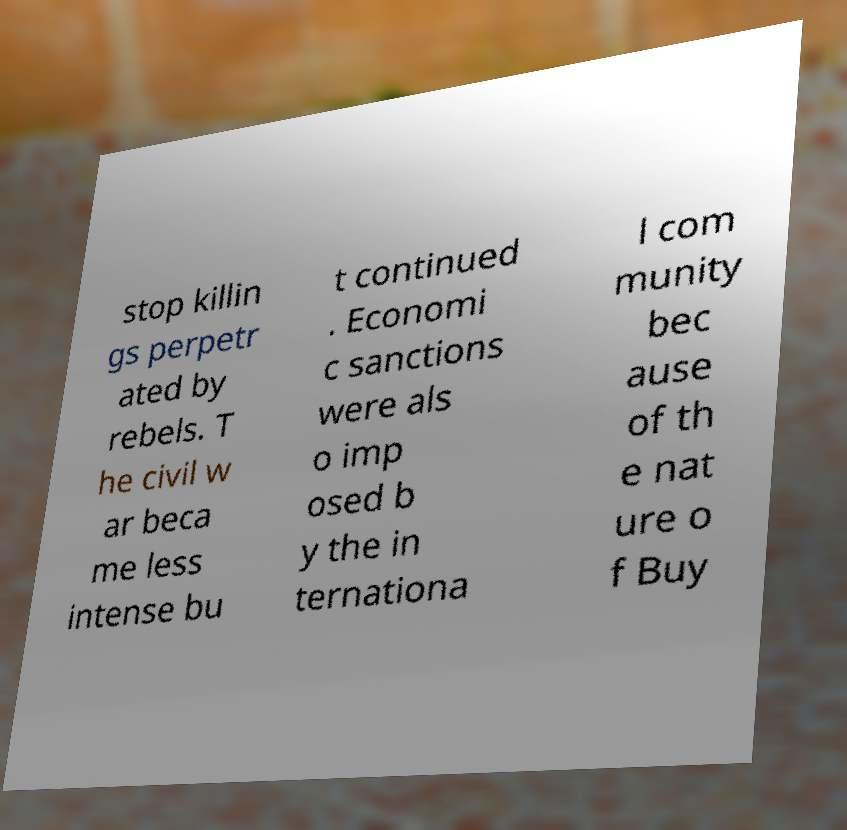For documentation purposes, I need the text within this image transcribed. Could you provide that? stop killin gs perpetr ated by rebels. T he civil w ar beca me less intense bu t continued . Economi c sanctions were als o imp osed b y the in ternationa l com munity bec ause of th e nat ure o f Buy 